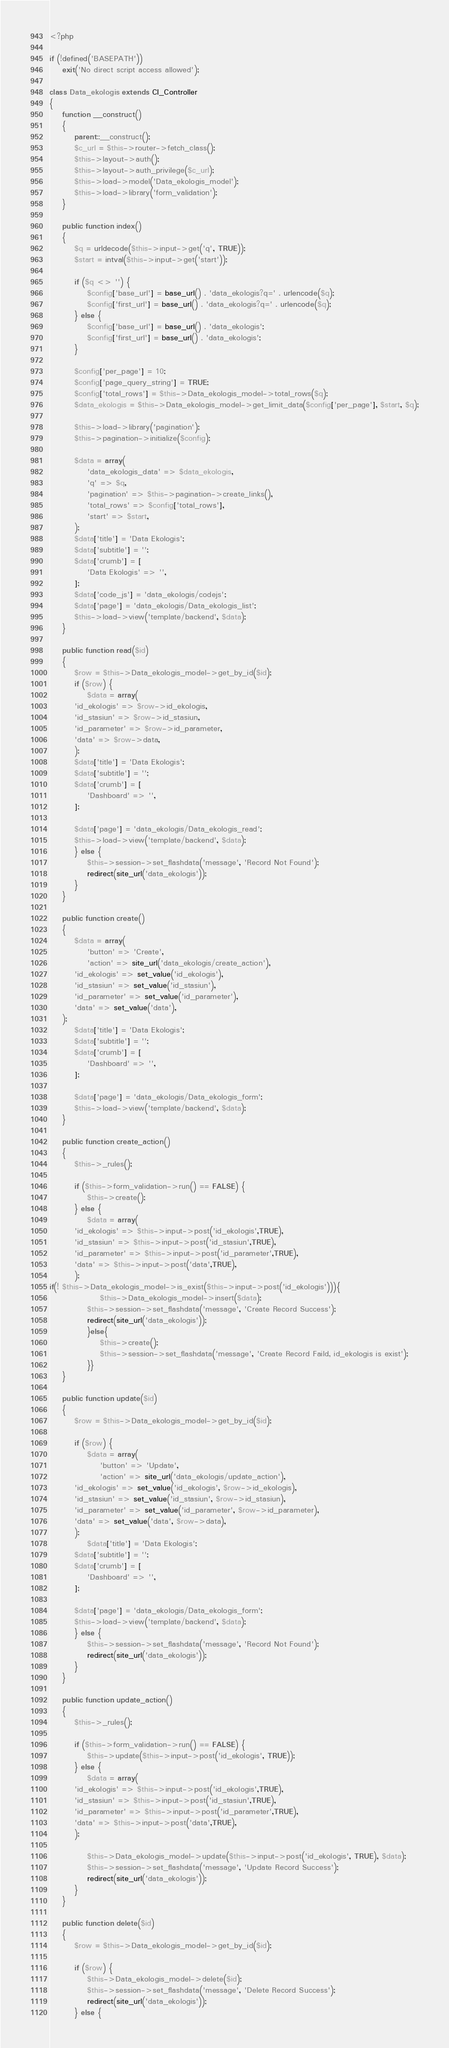<code> <loc_0><loc_0><loc_500><loc_500><_PHP_><?php

if (!defined('BASEPATH'))
    exit('No direct script access allowed');

class Data_ekologis extends CI_Controller
{
    function __construct()
    {
        parent::__construct();
        $c_url = $this->router->fetch_class();
        $this->layout->auth(); 
        $this->layout->auth_privilege($c_url);
        $this->load->model('Data_ekologis_model');
        $this->load->library('form_validation');
    }

    public function index()
    {
        $q = urldecode($this->input->get('q', TRUE));
        $start = intval($this->input->get('start'));
        
        if ($q <> '') {
            $config['base_url'] = base_url() . 'data_ekologis?q=' . urlencode($q);
            $config['first_url'] = base_url() . 'data_ekologis?q=' . urlencode($q);
        } else {
            $config['base_url'] = base_url() . 'data_ekologis';
            $config['first_url'] = base_url() . 'data_ekologis';
        }

        $config['per_page'] = 10;
        $config['page_query_string'] = TRUE;
        $config['total_rows'] = $this->Data_ekologis_model->total_rows($q);
        $data_ekologis = $this->Data_ekologis_model->get_limit_data($config['per_page'], $start, $q);

        $this->load->library('pagination');
        $this->pagination->initialize($config);

        $data = array(
            'data_ekologis_data' => $data_ekologis,
            'q' => $q,
            'pagination' => $this->pagination->create_links(),
            'total_rows' => $config['total_rows'],
            'start' => $start,
        );
        $data['title'] = 'Data Ekologis';
        $data['subtitle'] = '';
        $data['crumb'] = [
            'Data Ekologis' => '',
        ];
        $data['code_js'] = 'data_ekologis/codejs';
        $data['page'] = 'data_ekologis/Data_ekologis_list';
        $this->load->view('template/backend', $data);
    }

    public function read($id) 
    {
        $row = $this->Data_ekologis_model->get_by_id($id);
        if ($row) {
            $data = array(
		'id_ekologis' => $row->id_ekologis,
		'id_stasiun' => $row->id_stasiun,
		'id_parameter' => $row->id_parameter,
		'data' => $row->data,
	    );
        $data['title'] = 'Data Ekologis';
        $data['subtitle'] = '';
        $data['crumb'] = [
            'Dashboard' => '',
        ];

        $data['page'] = 'data_ekologis/Data_ekologis_read';
        $this->load->view('template/backend', $data);
        } else {
            $this->session->set_flashdata('message', 'Record Not Found');
            redirect(site_url('data_ekologis'));
        }
    }

    public function create() 
    {
        $data = array(
            'button' => 'Create',
            'action' => site_url('data_ekologis/create_action'),
	    'id_ekologis' => set_value('id_ekologis'),
	    'id_stasiun' => set_value('id_stasiun'),
	    'id_parameter' => set_value('id_parameter'),
	    'data' => set_value('data'),
	);
        $data['title'] = 'Data Ekologis';
        $data['subtitle'] = '';
        $data['crumb'] = [
            'Dashboard' => '',
        ];

        $data['page'] = 'data_ekologis/Data_ekologis_form';
        $this->load->view('template/backend', $data);
    }
    
    public function create_action() 
    {
        $this->_rules();

        if ($this->form_validation->run() == FALSE) {
            $this->create();
        } else {
            $data = array(
		'id_ekologis' => $this->input->post('id_ekologis',TRUE),
		'id_stasiun' => $this->input->post('id_stasiun',TRUE),
		'id_parameter' => $this->input->post('id_parameter',TRUE),
		'data' => $this->input->post('data',TRUE),
	    );
if(! $this->Data_ekologis_model->is_exist($this->input->post('id_ekologis'))){
                $this->Data_ekologis_model->insert($data);
            $this->session->set_flashdata('message', 'Create Record Success');
            redirect(site_url('data_ekologis'));
            }else{
                $this->create();
                $this->session->set_flashdata('message', 'Create Record Faild, id_ekologis is exist');
            }}
    }
    
    public function update($id) 
    {
        $row = $this->Data_ekologis_model->get_by_id($id);

        if ($row) {
            $data = array(
                'button' => 'Update',
                'action' => site_url('data_ekologis/update_action'),
		'id_ekologis' => set_value('id_ekologis', $row->id_ekologis),
		'id_stasiun' => set_value('id_stasiun', $row->id_stasiun),
		'id_parameter' => set_value('id_parameter', $row->id_parameter),
		'data' => set_value('data', $row->data),
	    );
            $data['title'] = 'Data Ekologis';
        $data['subtitle'] = '';
        $data['crumb'] = [
            'Dashboard' => '',
        ];

        $data['page'] = 'data_ekologis/Data_ekologis_form';
        $this->load->view('template/backend', $data);
        } else {
            $this->session->set_flashdata('message', 'Record Not Found');
            redirect(site_url('data_ekologis'));
        }
    }
    
    public function update_action() 
    {
        $this->_rules();

        if ($this->form_validation->run() == FALSE) {
            $this->update($this->input->post('id_ekologis', TRUE));
        } else {
            $data = array(
		'id_ekologis' => $this->input->post('id_ekologis',TRUE),
		'id_stasiun' => $this->input->post('id_stasiun',TRUE),
		'id_parameter' => $this->input->post('id_parameter',TRUE),
		'data' => $this->input->post('data',TRUE),
	    );

            $this->Data_ekologis_model->update($this->input->post('id_ekologis', TRUE), $data);
            $this->session->set_flashdata('message', 'Update Record Success');
            redirect(site_url('data_ekologis'));
        }
    }
    
    public function delete($id) 
    {
        $row = $this->Data_ekologis_model->get_by_id($id);

        if ($row) {
            $this->Data_ekologis_model->delete($id);
            $this->session->set_flashdata('message', 'Delete Record Success');
            redirect(site_url('data_ekologis'));
        } else {</code> 